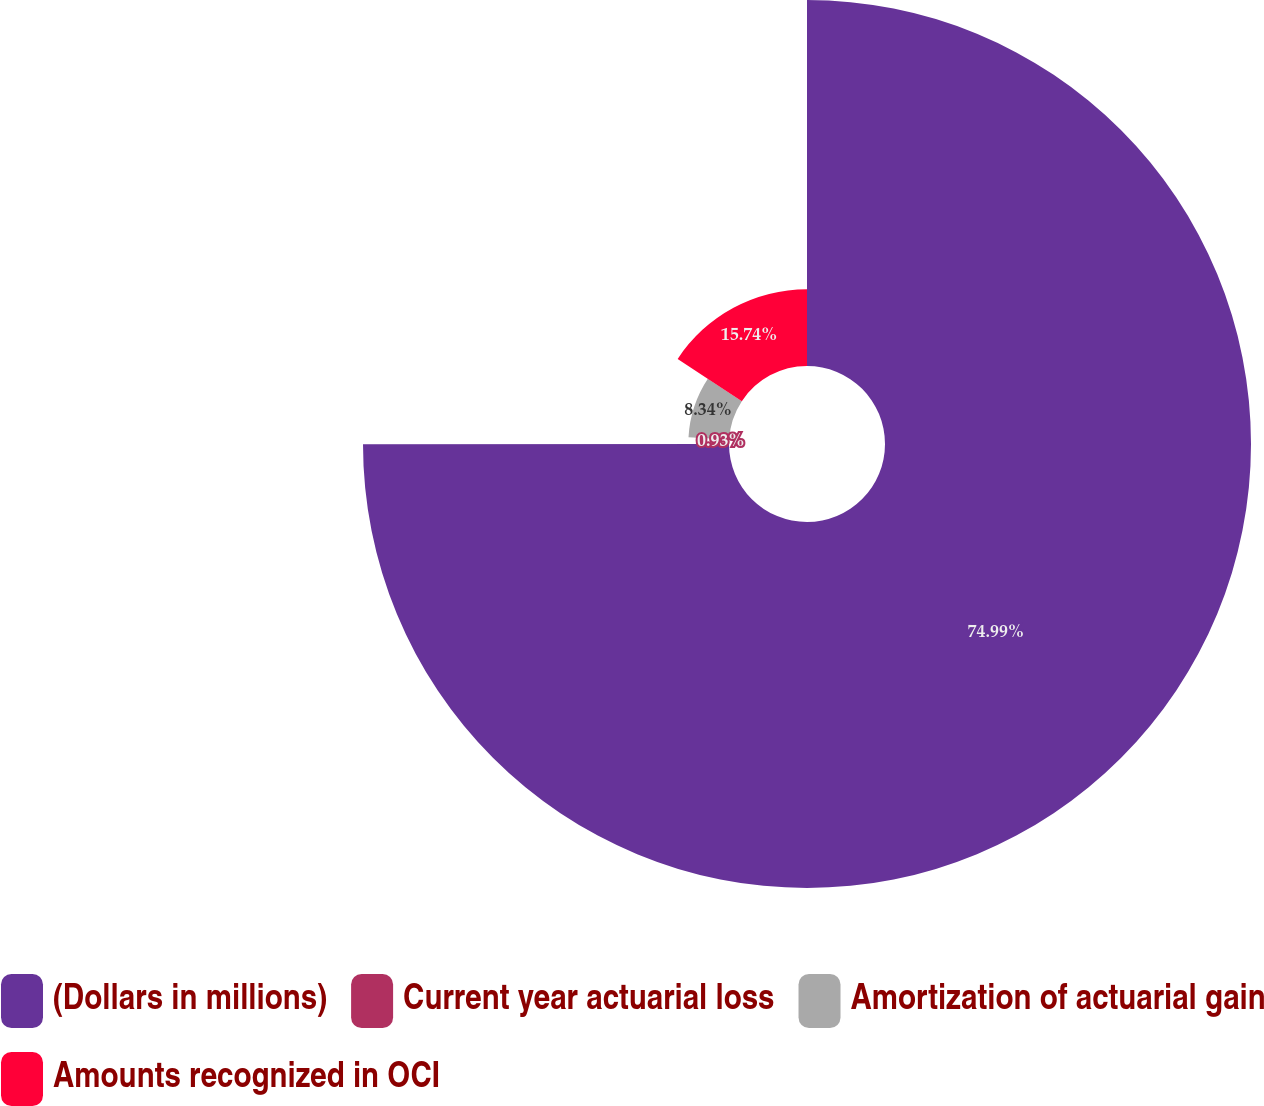Convert chart to OTSL. <chart><loc_0><loc_0><loc_500><loc_500><pie_chart><fcel>(Dollars in millions)<fcel>Current year actuarial loss<fcel>Amortization of actuarial gain<fcel>Amounts recognized in OCI<nl><fcel>74.99%<fcel>0.93%<fcel>8.34%<fcel>15.74%<nl></chart> 